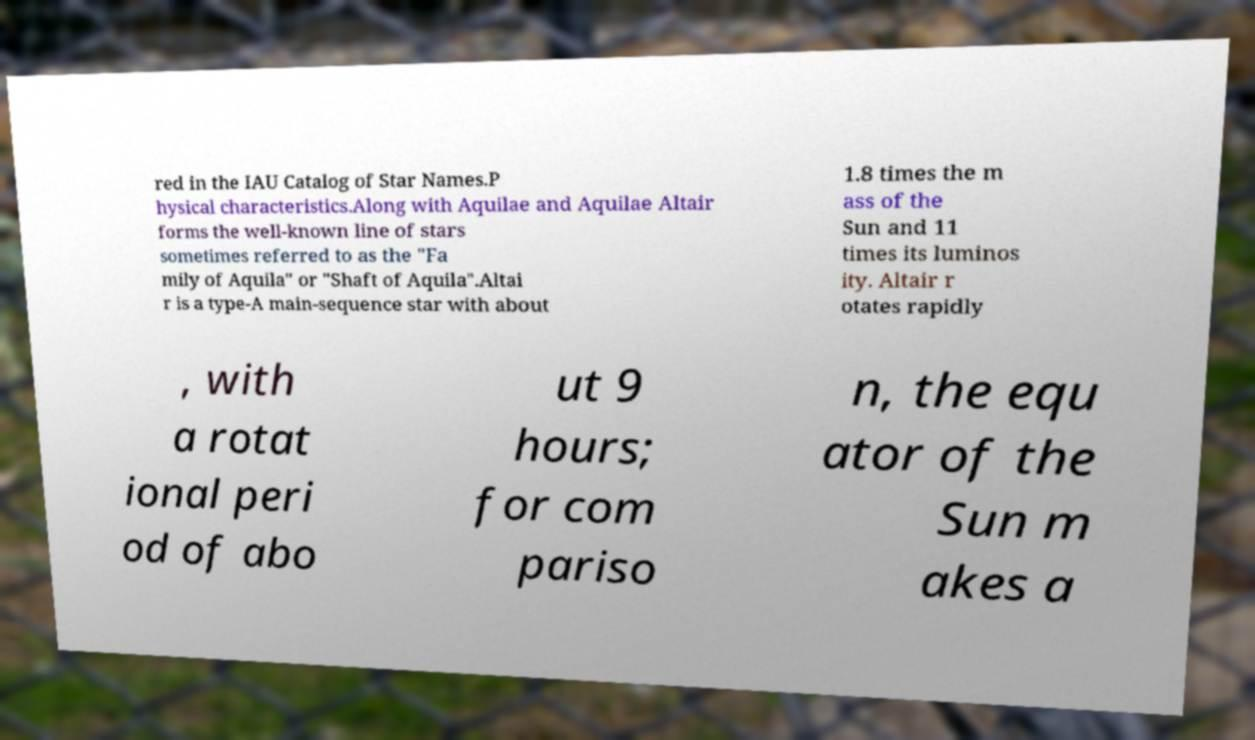Please read and relay the text visible in this image. What does it say? red in the IAU Catalog of Star Names.P hysical characteristics.Along with Aquilae and Aquilae Altair forms the well-known line of stars sometimes referred to as the "Fa mily of Aquila" or "Shaft of Aquila".Altai r is a type-A main-sequence star with about 1.8 times the m ass of the Sun and 11 times its luminos ity. Altair r otates rapidly , with a rotat ional peri od of abo ut 9 hours; for com pariso n, the equ ator of the Sun m akes a 